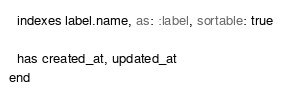Convert code to text. <code><loc_0><loc_0><loc_500><loc_500><_Ruby_>  indexes label.name, as: :label, sortable: true

  has created_at, updated_at
end
</code> 